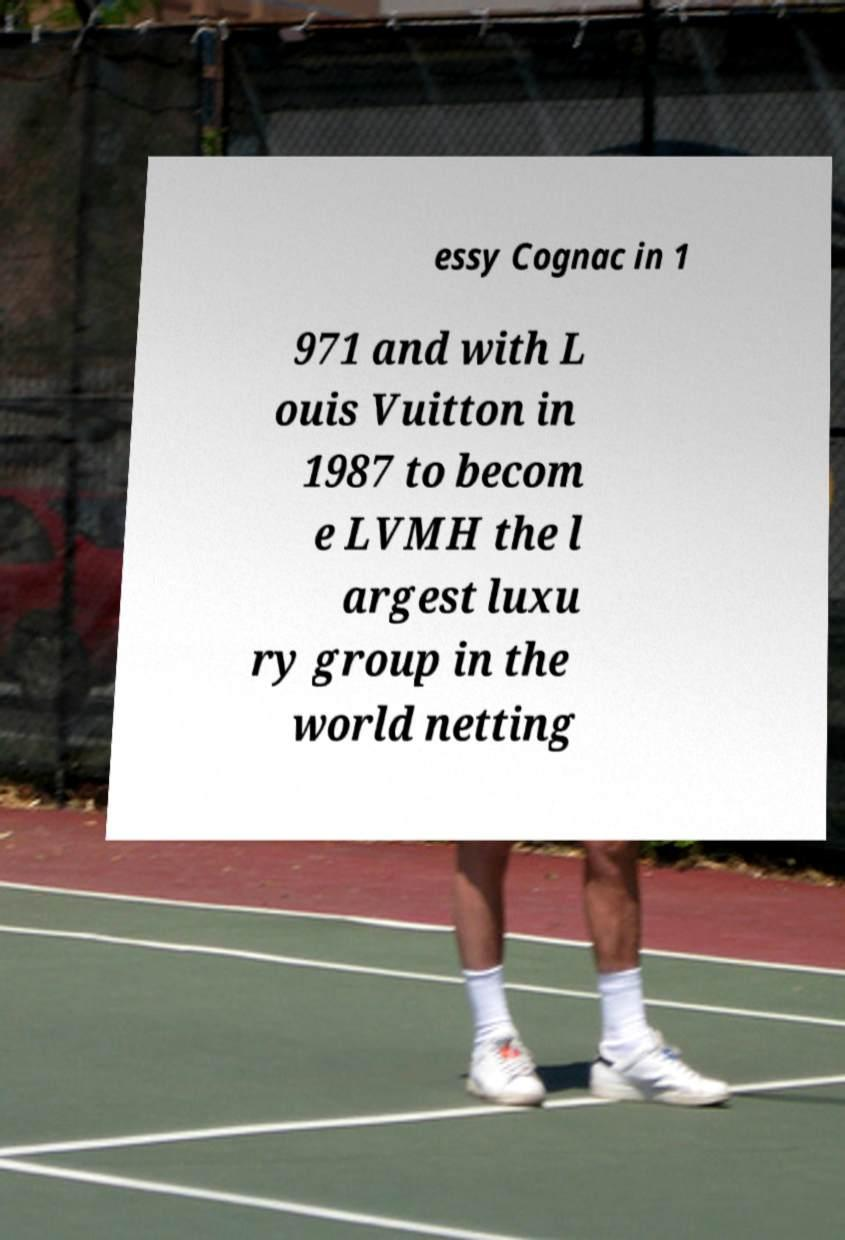I need the written content from this picture converted into text. Can you do that? essy Cognac in 1 971 and with L ouis Vuitton in 1987 to becom e LVMH the l argest luxu ry group in the world netting 